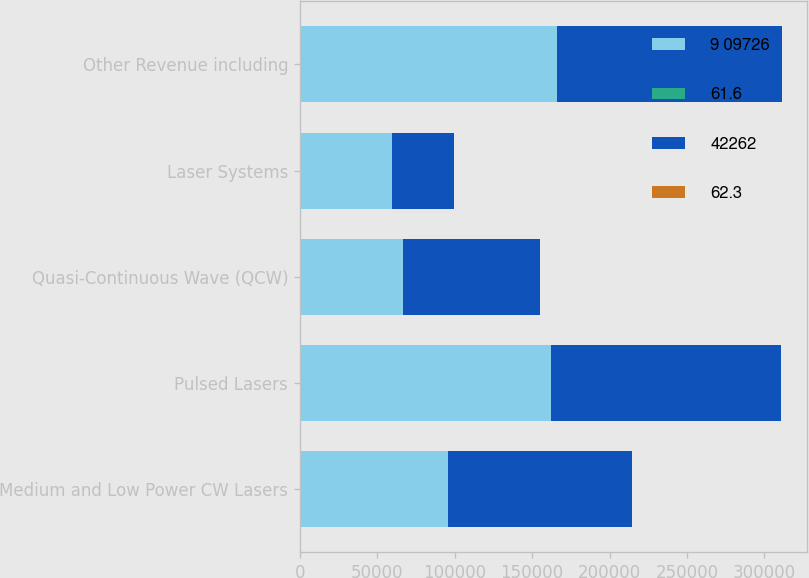<chart> <loc_0><loc_0><loc_500><loc_500><stacked_bar_chart><ecel><fcel>Medium and Low Power CW Lasers<fcel>Pulsed Lasers<fcel>Quasi-Continuous Wave (QCW)<fcel>Laser Systems<fcel>Other Revenue including<nl><fcel>9 09726<fcel>95764<fcel>162048<fcel>66700<fcel>59330<fcel>166306<nl><fcel>61.6<fcel>6.6<fcel>11.1<fcel>4.6<fcel>4.1<fcel>11.3<nl><fcel>42262<fcel>118705<fcel>148701<fcel>88329<fcel>40410<fcel>145280<nl><fcel>62.3<fcel>8.4<fcel>10.6<fcel>6.3<fcel>2.9<fcel>10.2<nl></chart> 